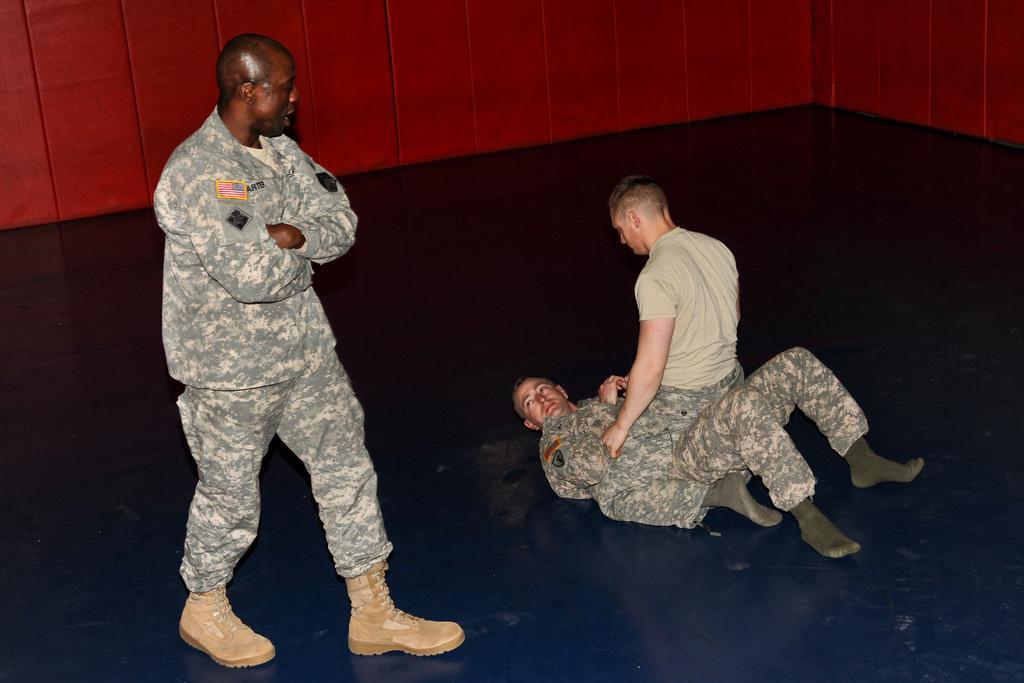In one or two sentences, can you explain what this image depicts? In this picture we can see three men and this is floor. In the background there is a wall. 